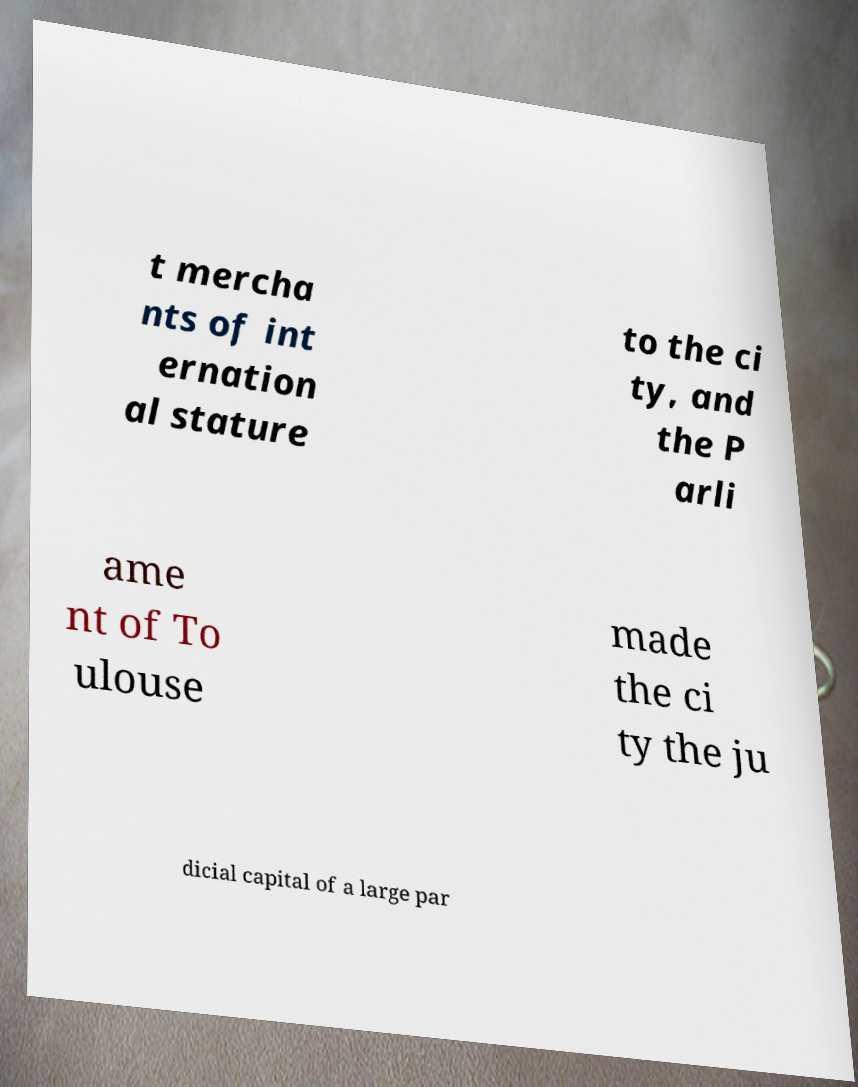Could you extract and type out the text from this image? t mercha nts of int ernation al stature to the ci ty, and the P arli ame nt of To ulouse made the ci ty the ju dicial capital of a large par 